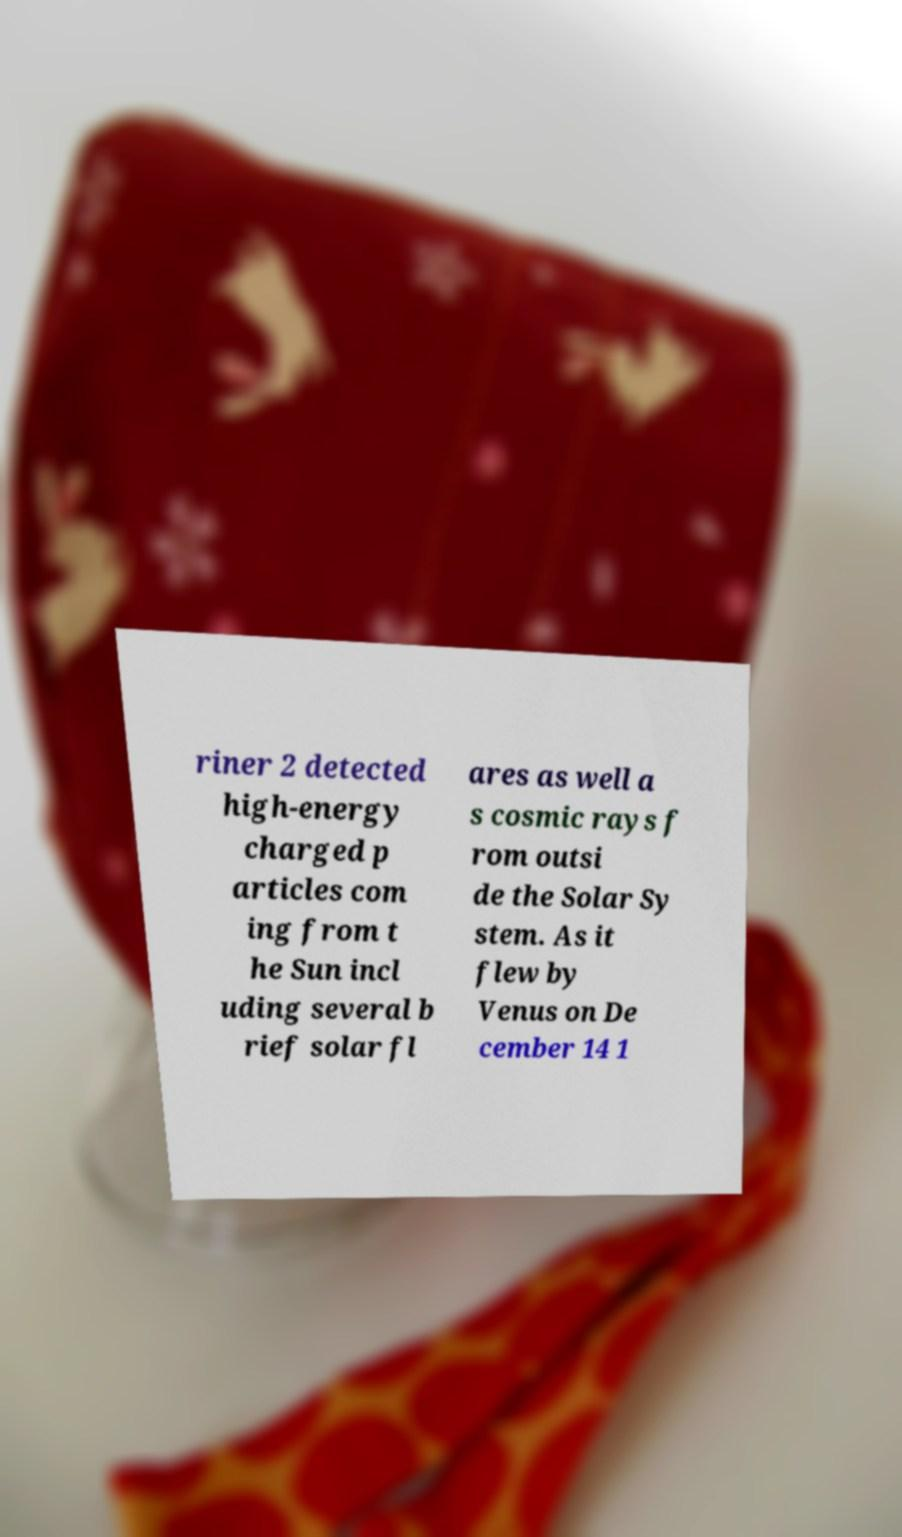Could you extract and type out the text from this image? riner 2 detected high-energy charged p articles com ing from t he Sun incl uding several b rief solar fl ares as well a s cosmic rays f rom outsi de the Solar Sy stem. As it flew by Venus on De cember 14 1 